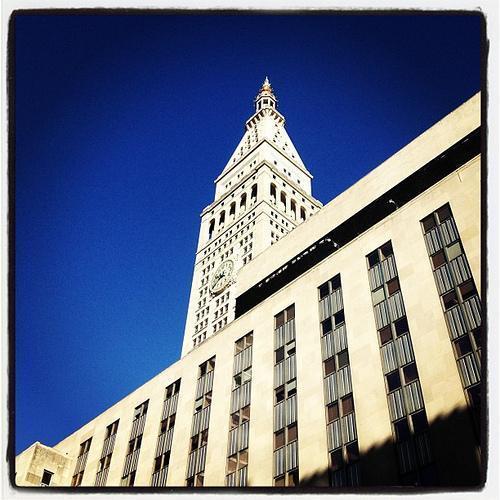How many buildings are there?
Give a very brief answer. 1. 